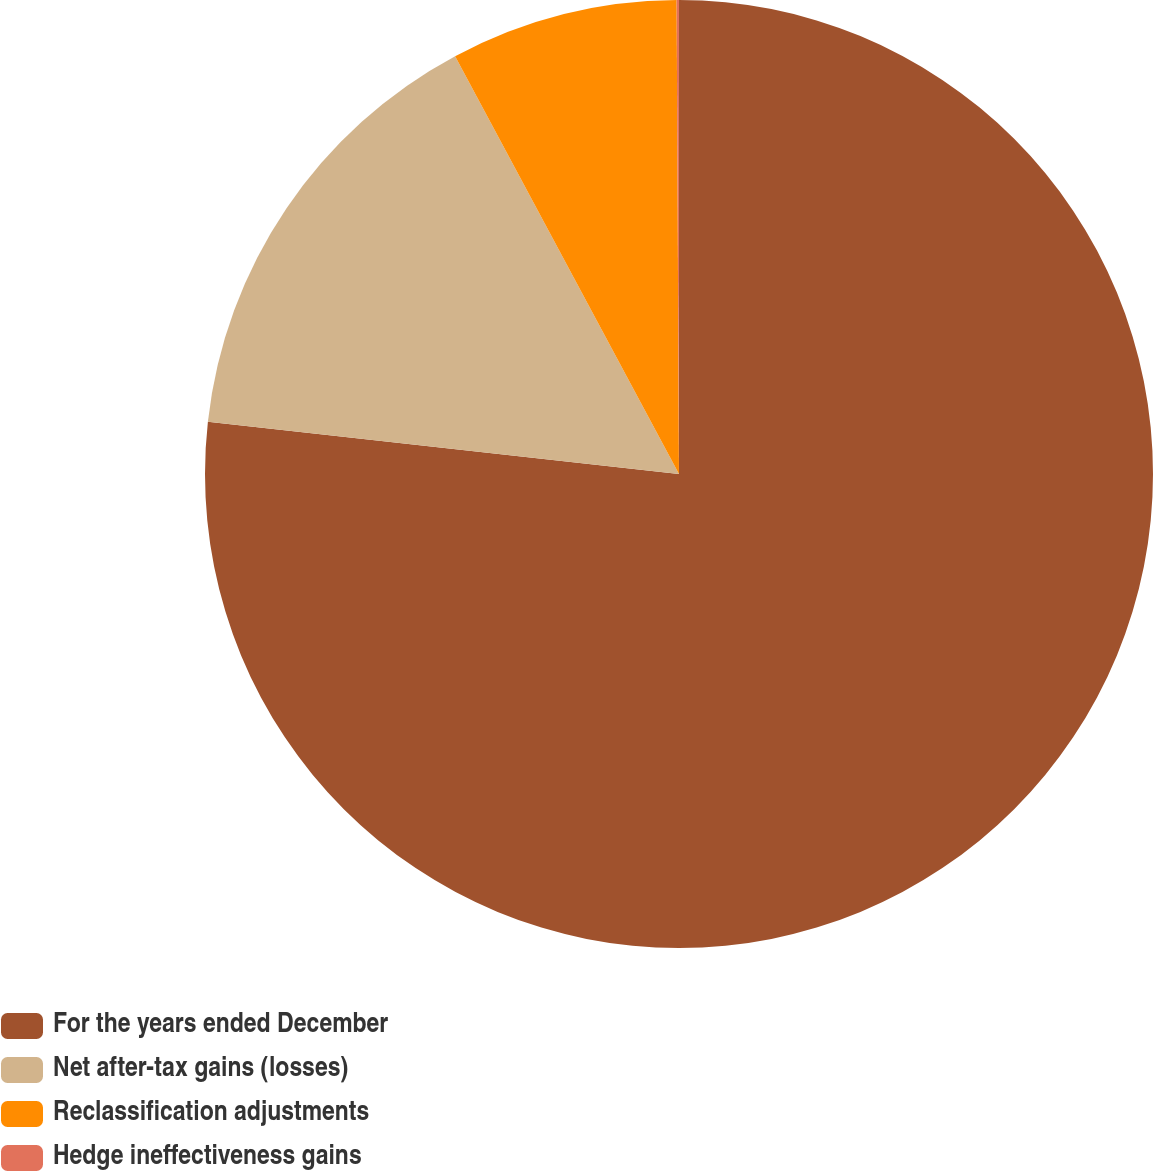Convert chart. <chart><loc_0><loc_0><loc_500><loc_500><pie_chart><fcel>For the years ended December<fcel>Net after-tax gains (losses)<fcel>Reclassification adjustments<fcel>Hedge ineffectiveness gains<nl><fcel>76.76%<fcel>15.41%<fcel>7.75%<fcel>0.08%<nl></chart> 